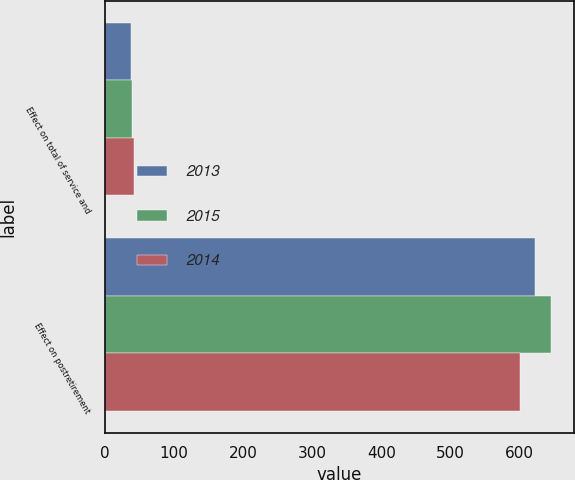<chart> <loc_0><loc_0><loc_500><loc_500><stacked_bar_chart><ecel><fcel>Effect on total of service and<fcel>Effect on postretirement<nl><fcel>2013<fcel>38<fcel>622<nl><fcel>2015<fcel>39<fcel>646<nl><fcel>2014<fcel>43<fcel>601<nl></chart> 